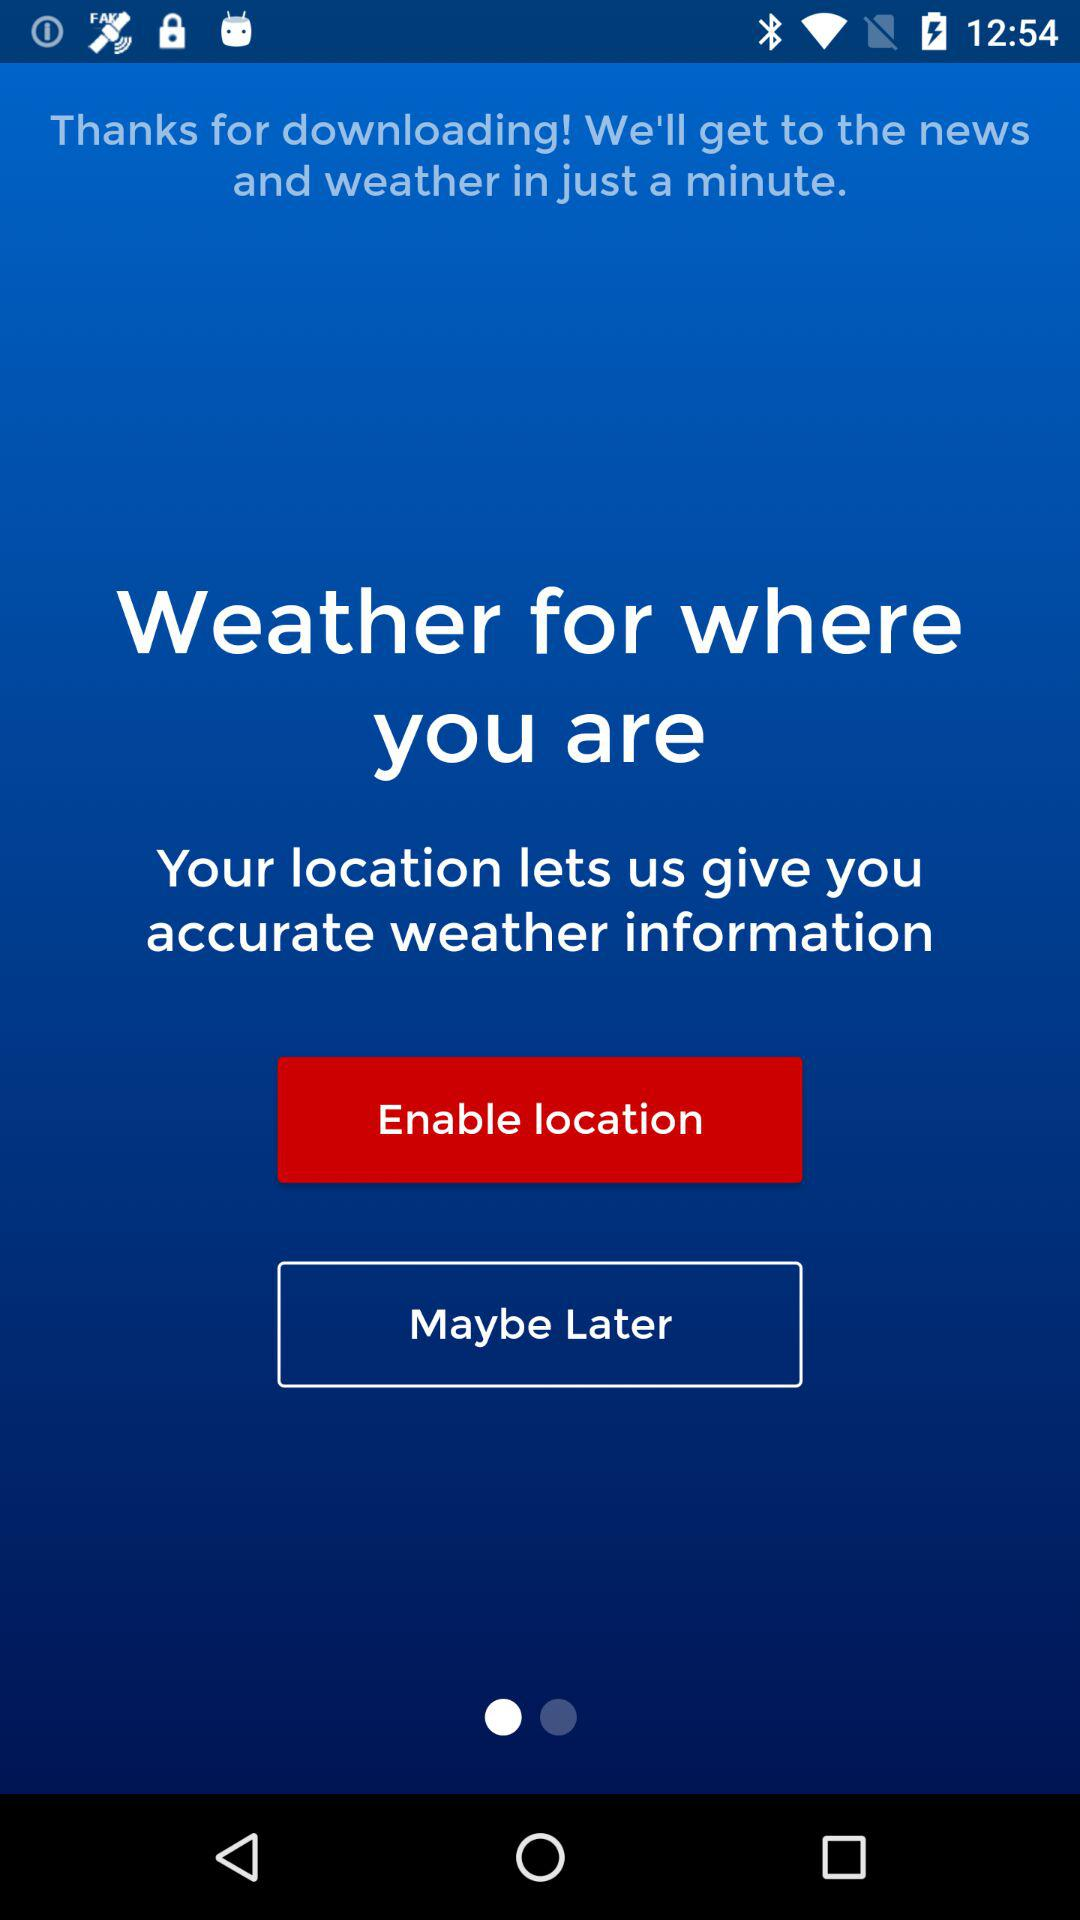What is the application name?
When the provided information is insufficient, respond with <no answer>. <no answer> 